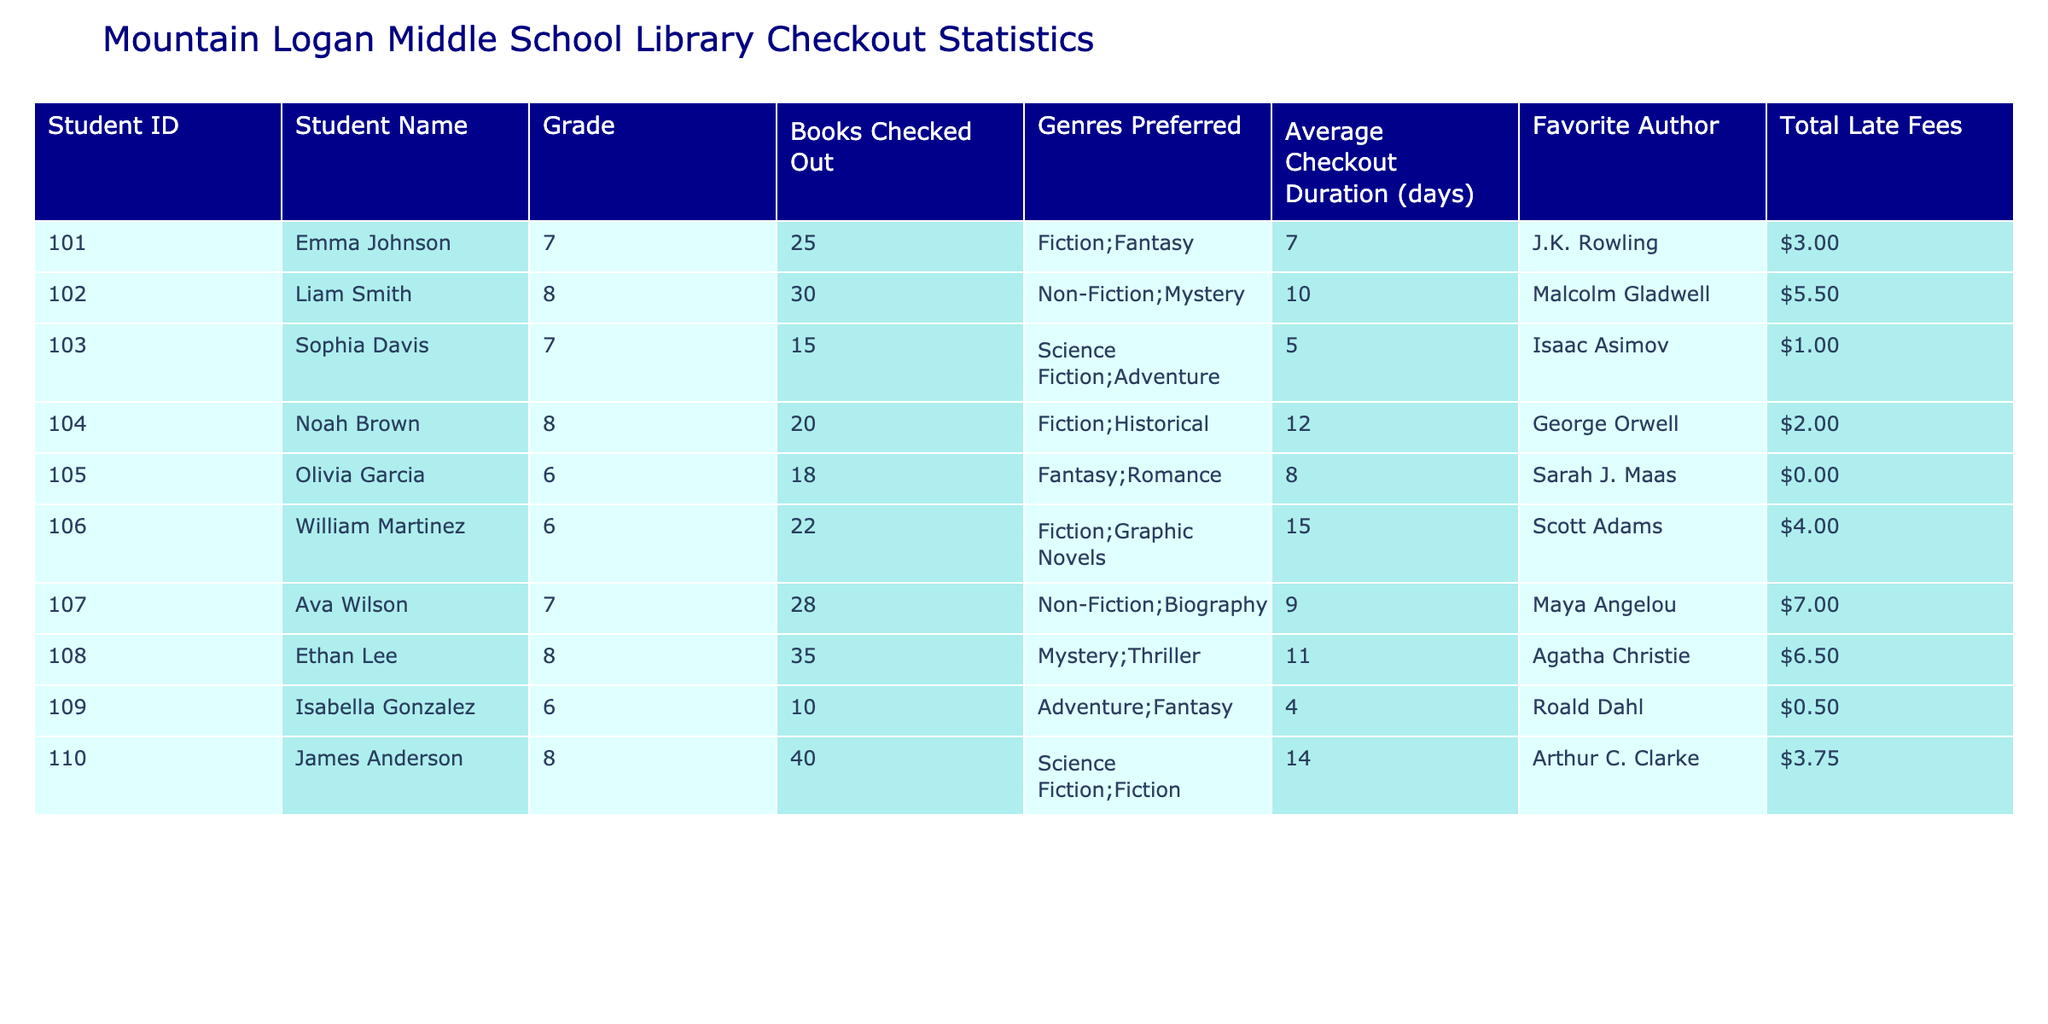What is the total number of books checked out by the student with the highest late fees? By reviewing the table, I identify the student with the highest late fees, which is Ava Wilson with $7.00. Then, I check how many books she has checked out, which is 28.
Answer: 28 Which grade has the highest average checkout duration? I can calculate the average checkout duration for each grade based on the data. For grades 6, 7, and 8: Grade 6 has an average duration of (8 + 15 + 4)/3 = 9; Grade 7 has (7 + 5 + 9)/3 = 7; Grade 8 has (10 + 12 + 11 + 14)/4 = 11. The highest average checkout duration is for Grade 8 at 11 days.
Answer: Grade 8 How many students checked out more than 20 books? I can count the students who have checked out more than 20 books by looking at the "Books Checked Out" column. The students with more than 20 books are Liam Smith (30), Ethan Lee (35), and James Anderson (40). In total, there are 4 students.
Answer: 4 Is there a student who has not paid any late fees? I check the "Total Late Fees" column for any students with a $0.00 fee. Olivia Garcia and Isabella Gonzalez both have $0.00 late fees, confirming that there are indeed students who have not paid any late fees.
Answer: Yes What is the average number of books checked out by students in Grade 6? I first find the students in Grade 6: Olivia Garcia (18), William Martinez (22), and Isabella Gonzalez (10). I sum their books checked out: 18 + 22 + 10 = 50. There are 3 students, so the average is 50/3 ≈ 16.67.
Answer: 16.67 Who is the favorite author for the student who checked out the least number of books? The student who checked out the least number of books is Isabella Gonzalez, with 10 books. The favorite author listed for her is Roald Dahl.
Answer: Roald Dahl Which genre is preferred by the student who has the highest total late fees? I identify the student with the highest total late fees, Ava Wilson, who prefers Non-Fiction and Biography genres.
Answer: Non-Fiction; Biography What is the sum of late fees for students in Grade 8? The late fees for students in Grade 8 are: Liam Smith ($5.50) + Noah Brown ($2.00) + Ethan Lee ($6.50) + James Anderson ($3.75), which adds up to $5.50 + $2.00 + $6.50 + $3.75 = $17.75.
Answer: $17.75 How many students preferred Fantasy as one of their genres? Looking at the "Genres Preferred" column, I find students who have Fantasy listed: Emma Johnson, Olivia Garcia, and Isabella Gonzalez. There are 3 students who prefer Fantasy.
Answer: 3 Do more students prefer Fiction or Non-Fiction? I count students preferring Fiction: Emma Johnson, Noah Brown, William Martinez, and James Anderson, totaling 4. For Non-Fiction, I see Ava Wilson, Liam Smith, and Ethan Lee, totaling 3 students. Fiction is preferred by more students.
Answer: Yes What percentage of checked-out books belong to Grade 7? I first find the total books checked out across all grades: 25 + 30 + 15 + 20 + 18 + 22 + 28 + 35 + 10 + 40 =  2. The number of books checked out by Grade 7 students is 25 + 15 + 28 = 68. The percentage is (68/ 2) * 100 = 34%.
Answer: 34% 